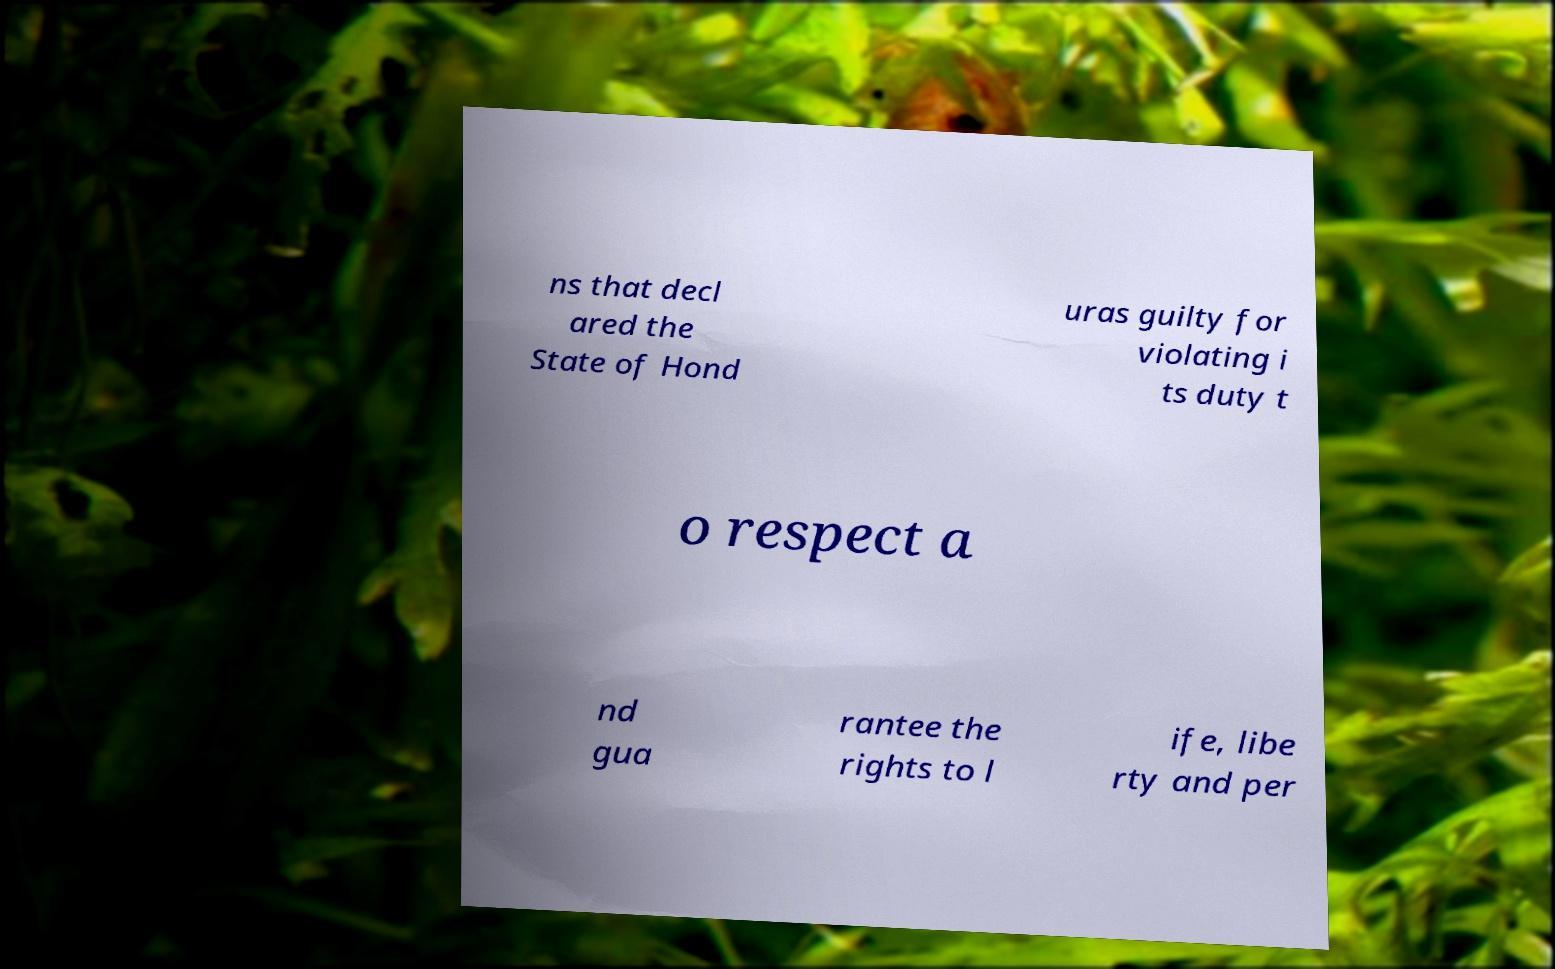There's text embedded in this image that I need extracted. Can you transcribe it verbatim? ns that decl ared the State of Hond uras guilty for violating i ts duty t o respect a nd gua rantee the rights to l ife, libe rty and per 